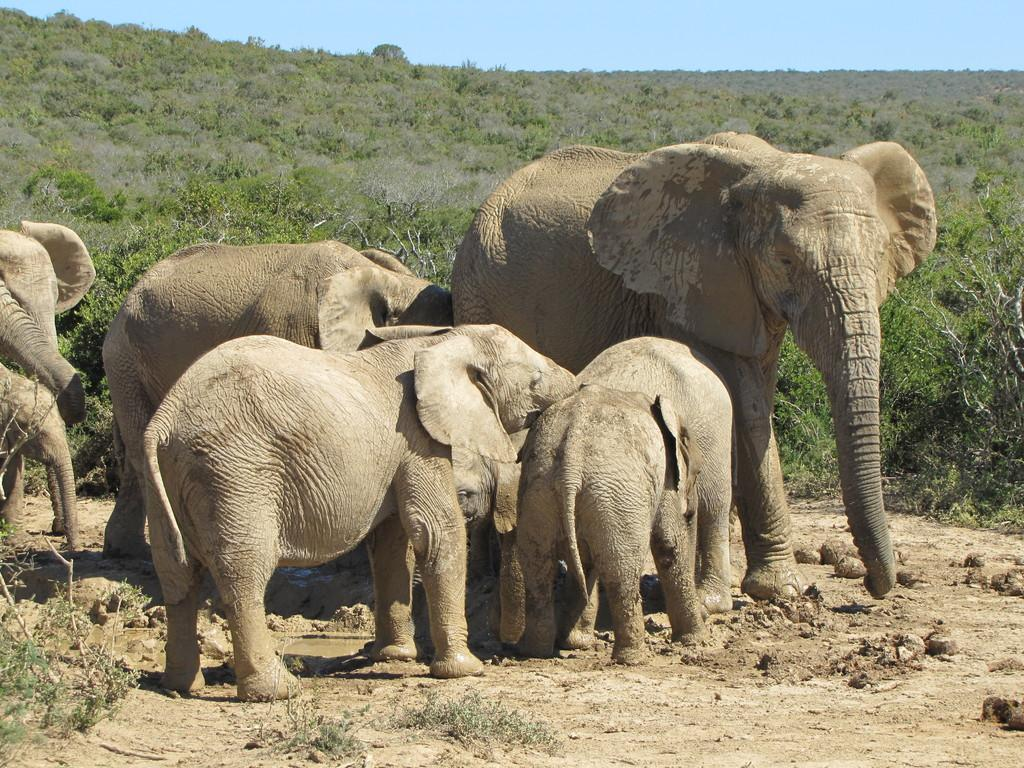What animals are present in the image? There is a herd of elephants in the image. Where are the elephants located in the image? The elephants are standing in the middle of the image. What can be seen in the background of the image? There are trees visible in the background of the image. What type of crate is being used to transport the elephants in the image? There is no crate present in the image; the elephants are standing in the middle of the image. What story is being told by the elephants in the image? The image does not depict a story being told by the elephants; it simply shows a herd of elephants standing in the middle of the image. 